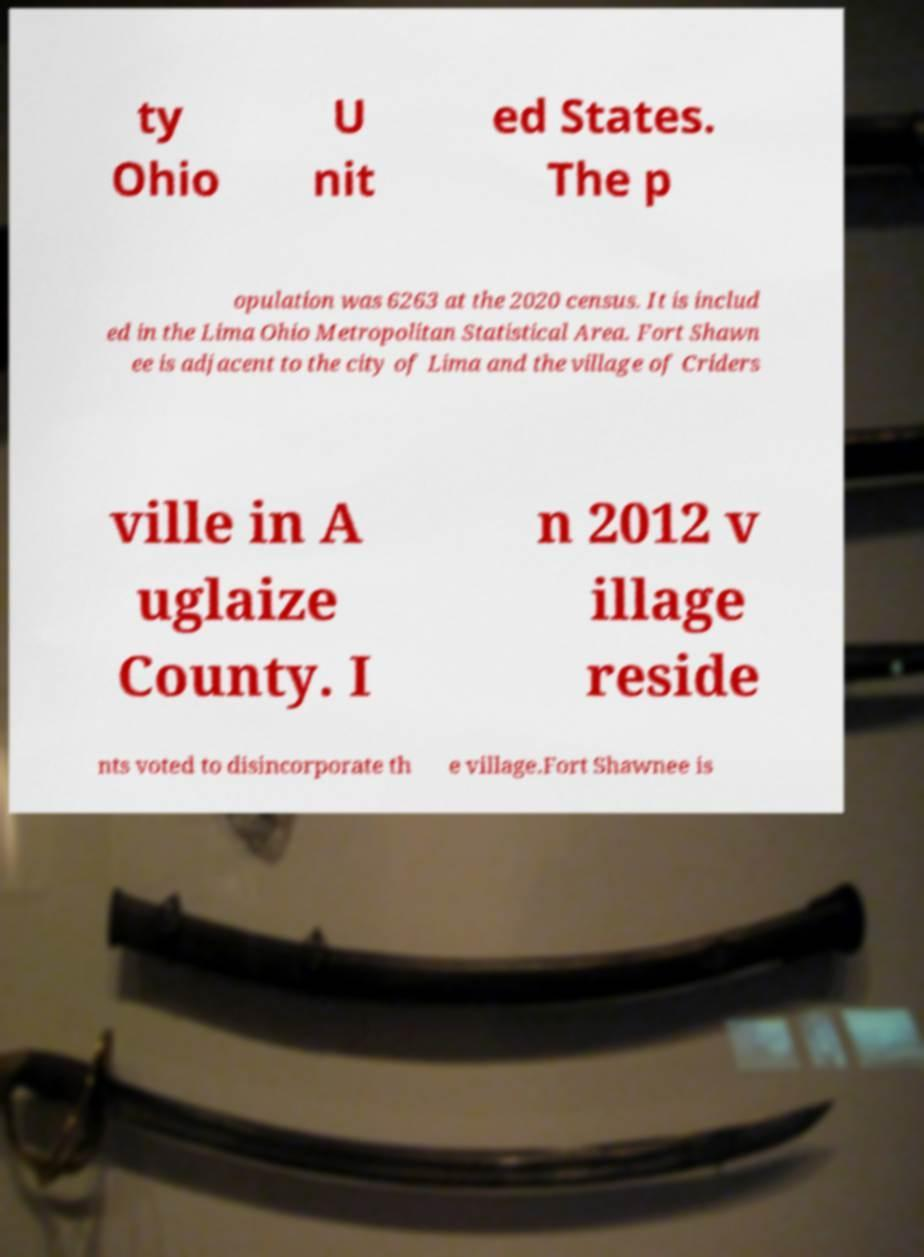Could you extract and type out the text from this image? ty Ohio U nit ed States. The p opulation was 6263 at the 2020 census. It is includ ed in the Lima Ohio Metropolitan Statistical Area. Fort Shawn ee is adjacent to the city of Lima and the village of Criders ville in A uglaize County. I n 2012 v illage reside nts voted to disincorporate th e village.Fort Shawnee is 